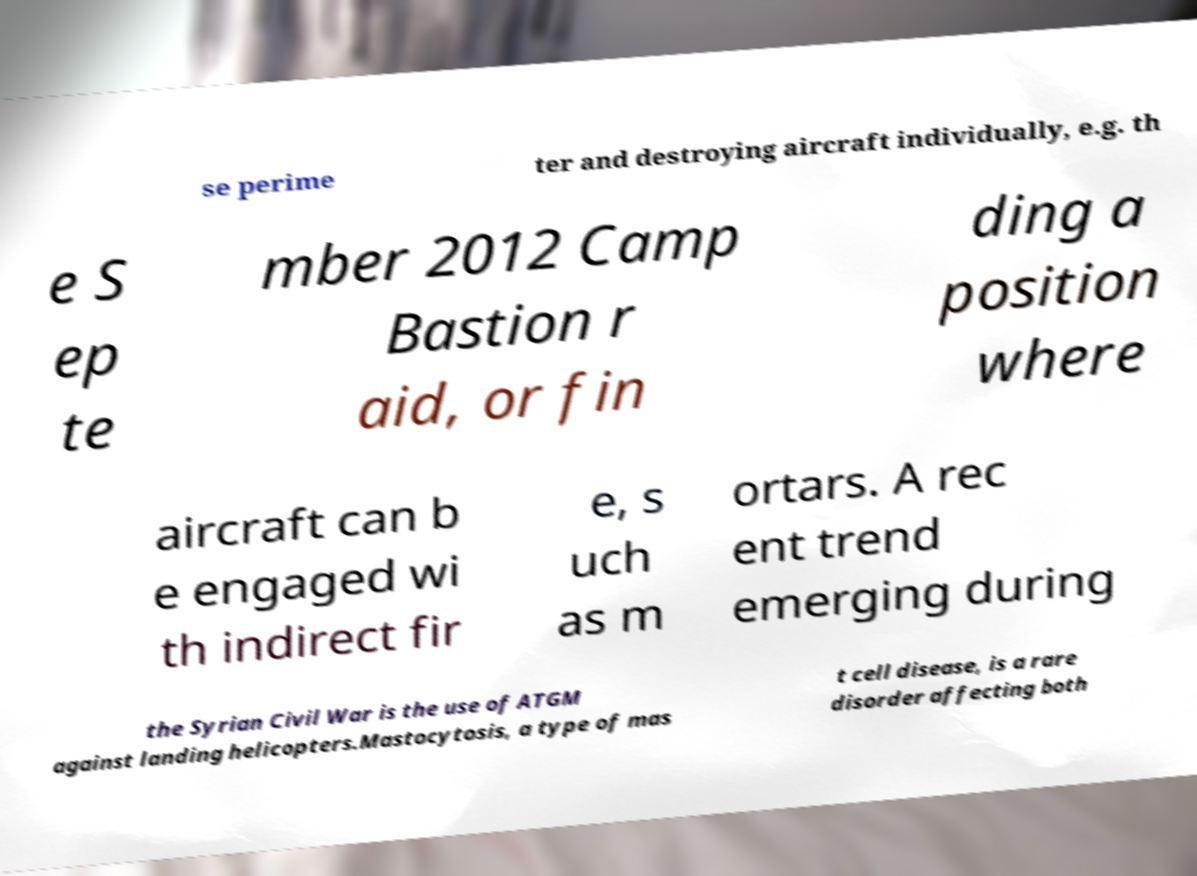Could you extract and type out the text from this image? se perime ter and destroying aircraft individually, e.g. th e S ep te mber 2012 Camp Bastion r aid, or fin ding a position where aircraft can b e engaged wi th indirect fir e, s uch as m ortars. A rec ent trend emerging during the Syrian Civil War is the use of ATGM against landing helicopters.Mastocytosis, a type of mas t cell disease, is a rare disorder affecting both 